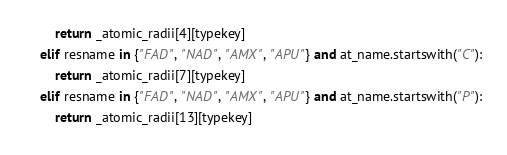<code> <loc_0><loc_0><loc_500><loc_500><_Python_>        return _atomic_radii[4][typekey]
    elif resname in {"FAD", "NAD", "AMX", "APU"} and at_name.startswith("C"):
        return _atomic_radii[7][typekey]
    elif resname in {"FAD", "NAD", "AMX", "APU"} and at_name.startswith("P"):
        return _atomic_radii[13][typekey]</code> 